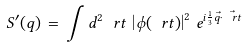<formula> <loc_0><loc_0><loc_500><loc_500>S ^ { \prime } ( q ) \, = \, \int d ^ { 2 } \ r t \, \left | \phi ( \ r t ) \right | ^ { 2 } \, e ^ { i \frac { 1 } { 3 } \vec { q } \cdot \vec { \ r t } }</formula> 